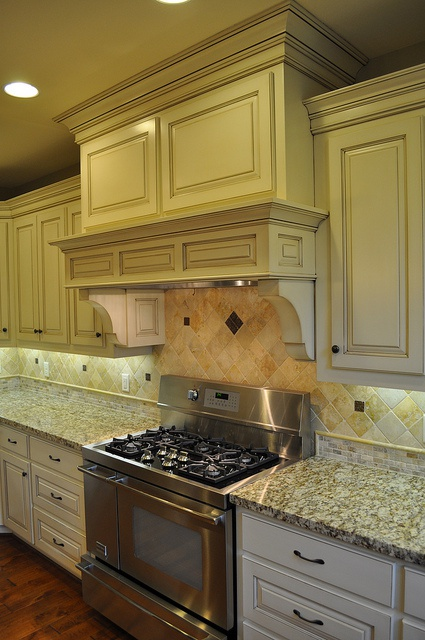Describe the objects in this image and their specific colors. I can see a oven in olive, black, and gray tones in this image. 